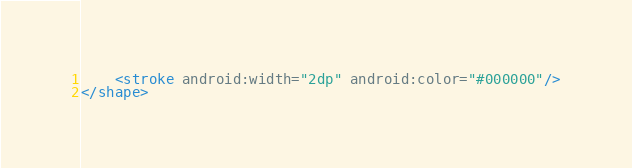<code> <loc_0><loc_0><loc_500><loc_500><_XML_>    <stroke android:width="2dp" android:color="#000000"/>
</shape></code> 